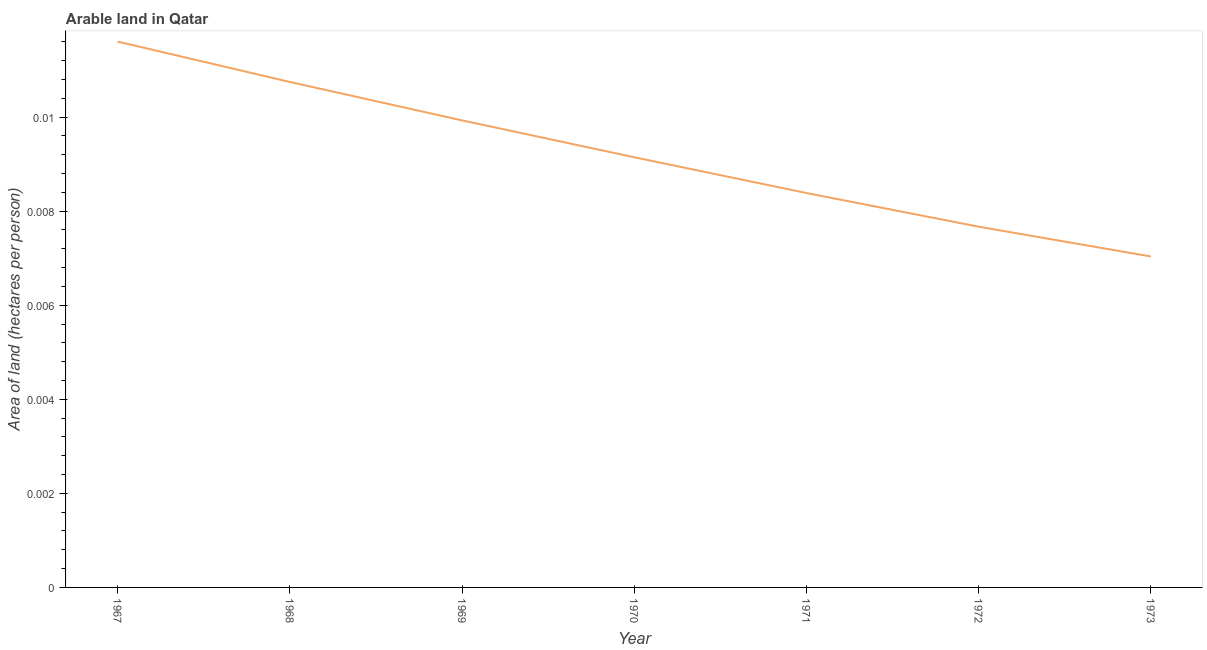What is the area of arable land in 1971?
Make the answer very short. 0.01. Across all years, what is the maximum area of arable land?
Make the answer very short. 0.01. Across all years, what is the minimum area of arable land?
Offer a terse response. 0.01. In which year was the area of arable land maximum?
Your response must be concise. 1967. In which year was the area of arable land minimum?
Keep it short and to the point. 1973. What is the sum of the area of arable land?
Ensure brevity in your answer.  0.06. What is the difference between the area of arable land in 1971 and 1972?
Your answer should be compact. 0. What is the average area of arable land per year?
Provide a succinct answer. 0.01. What is the median area of arable land?
Your answer should be very brief. 0.01. In how many years, is the area of arable land greater than 0.0036 hectares per person?
Provide a short and direct response. 7. What is the ratio of the area of arable land in 1968 to that in 1970?
Your answer should be very brief. 1.18. Is the area of arable land in 1967 less than that in 1972?
Provide a short and direct response. No. What is the difference between the highest and the second highest area of arable land?
Keep it short and to the point. 0. What is the difference between the highest and the lowest area of arable land?
Keep it short and to the point. 0. How many lines are there?
Offer a terse response. 1. How many years are there in the graph?
Keep it short and to the point. 7. What is the difference between two consecutive major ticks on the Y-axis?
Your answer should be very brief. 0. Does the graph contain grids?
Offer a very short reply. No. What is the title of the graph?
Your response must be concise. Arable land in Qatar. What is the label or title of the Y-axis?
Offer a very short reply. Area of land (hectares per person). What is the Area of land (hectares per person) of 1967?
Your answer should be compact. 0.01. What is the Area of land (hectares per person) in 1968?
Your answer should be very brief. 0.01. What is the Area of land (hectares per person) in 1969?
Give a very brief answer. 0.01. What is the Area of land (hectares per person) in 1970?
Make the answer very short. 0.01. What is the Area of land (hectares per person) of 1971?
Give a very brief answer. 0.01. What is the Area of land (hectares per person) of 1972?
Give a very brief answer. 0.01. What is the Area of land (hectares per person) in 1973?
Your answer should be compact. 0.01. What is the difference between the Area of land (hectares per person) in 1967 and 1968?
Your answer should be very brief. 0. What is the difference between the Area of land (hectares per person) in 1967 and 1969?
Ensure brevity in your answer.  0. What is the difference between the Area of land (hectares per person) in 1967 and 1970?
Offer a very short reply. 0. What is the difference between the Area of land (hectares per person) in 1967 and 1971?
Offer a very short reply. 0. What is the difference between the Area of land (hectares per person) in 1967 and 1972?
Give a very brief answer. 0. What is the difference between the Area of land (hectares per person) in 1967 and 1973?
Offer a very short reply. 0. What is the difference between the Area of land (hectares per person) in 1968 and 1969?
Offer a terse response. 0. What is the difference between the Area of land (hectares per person) in 1968 and 1970?
Provide a succinct answer. 0. What is the difference between the Area of land (hectares per person) in 1968 and 1971?
Your answer should be compact. 0. What is the difference between the Area of land (hectares per person) in 1968 and 1972?
Provide a short and direct response. 0. What is the difference between the Area of land (hectares per person) in 1968 and 1973?
Your answer should be very brief. 0. What is the difference between the Area of land (hectares per person) in 1969 and 1970?
Keep it short and to the point. 0. What is the difference between the Area of land (hectares per person) in 1969 and 1971?
Make the answer very short. 0. What is the difference between the Area of land (hectares per person) in 1969 and 1972?
Give a very brief answer. 0. What is the difference between the Area of land (hectares per person) in 1969 and 1973?
Keep it short and to the point. 0. What is the difference between the Area of land (hectares per person) in 1970 and 1971?
Your response must be concise. 0. What is the difference between the Area of land (hectares per person) in 1970 and 1972?
Make the answer very short. 0. What is the difference between the Area of land (hectares per person) in 1970 and 1973?
Your response must be concise. 0. What is the difference between the Area of land (hectares per person) in 1971 and 1972?
Give a very brief answer. 0. What is the difference between the Area of land (hectares per person) in 1971 and 1973?
Provide a short and direct response. 0. What is the difference between the Area of land (hectares per person) in 1972 and 1973?
Your response must be concise. 0. What is the ratio of the Area of land (hectares per person) in 1967 to that in 1968?
Ensure brevity in your answer.  1.08. What is the ratio of the Area of land (hectares per person) in 1967 to that in 1969?
Your response must be concise. 1.17. What is the ratio of the Area of land (hectares per person) in 1967 to that in 1970?
Ensure brevity in your answer.  1.27. What is the ratio of the Area of land (hectares per person) in 1967 to that in 1971?
Provide a short and direct response. 1.38. What is the ratio of the Area of land (hectares per person) in 1967 to that in 1972?
Offer a terse response. 1.51. What is the ratio of the Area of land (hectares per person) in 1967 to that in 1973?
Give a very brief answer. 1.65. What is the ratio of the Area of land (hectares per person) in 1968 to that in 1969?
Make the answer very short. 1.08. What is the ratio of the Area of land (hectares per person) in 1968 to that in 1970?
Give a very brief answer. 1.18. What is the ratio of the Area of land (hectares per person) in 1968 to that in 1971?
Keep it short and to the point. 1.28. What is the ratio of the Area of land (hectares per person) in 1968 to that in 1972?
Your answer should be very brief. 1.4. What is the ratio of the Area of land (hectares per person) in 1968 to that in 1973?
Make the answer very short. 1.53. What is the ratio of the Area of land (hectares per person) in 1969 to that in 1970?
Provide a succinct answer. 1.09. What is the ratio of the Area of land (hectares per person) in 1969 to that in 1971?
Provide a succinct answer. 1.18. What is the ratio of the Area of land (hectares per person) in 1969 to that in 1972?
Give a very brief answer. 1.29. What is the ratio of the Area of land (hectares per person) in 1969 to that in 1973?
Provide a short and direct response. 1.41. What is the ratio of the Area of land (hectares per person) in 1970 to that in 1971?
Your response must be concise. 1.09. What is the ratio of the Area of land (hectares per person) in 1970 to that in 1972?
Give a very brief answer. 1.19. What is the ratio of the Area of land (hectares per person) in 1971 to that in 1972?
Make the answer very short. 1.09. What is the ratio of the Area of land (hectares per person) in 1971 to that in 1973?
Your response must be concise. 1.19. What is the ratio of the Area of land (hectares per person) in 1972 to that in 1973?
Your response must be concise. 1.09. 